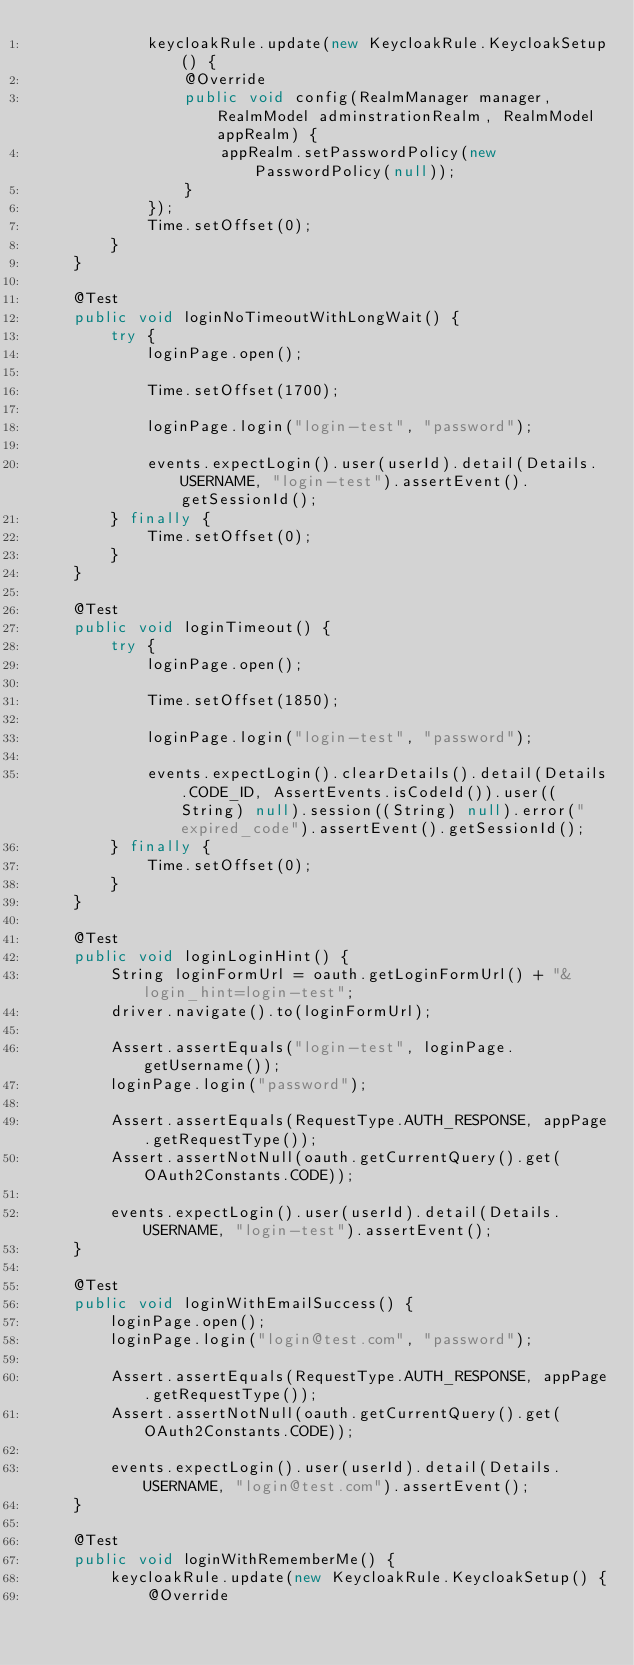Convert code to text. <code><loc_0><loc_0><loc_500><loc_500><_Java_>            keycloakRule.update(new KeycloakRule.KeycloakSetup() {
                @Override
                public void config(RealmManager manager, RealmModel adminstrationRealm, RealmModel appRealm) {
                    appRealm.setPasswordPolicy(new PasswordPolicy(null));
                }
            });
            Time.setOffset(0);
        }
    }
    
    @Test
    public void loginNoTimeoutWithLongWait() {
        try {
            loginPage.open();

            Time.setOffset(1700);

            loginPage.login("login-test", "password");

            events.expectLogin().user(userId).detail(Details.USERNAME, "login-test").assertEvent().getSessionId();
        } finally {
            Time.setOffset(0);
        }
    }

    @Test
    public void loginTimeout() {
        try {
            loginPage.open();

            Time.setOffset(1850);

            loginPage.login("login-test", "password");

            events.expectLogin().clearDetails().detail(Details.CODE_ID, AssertEvents.isCodeId()).user((String) null).session((String) null).error("expired_code").assertEvent().getSessionId();
        } finally {
            Time.setOffset(0);
        }
    }

    @Test
    public void loginLoginHint() {
        String loginFormUrl = oauth.getLoginFormUrl() + "&login_hint=login-test";
        driver.navigate().to(loginFormUrl);

        Assert.assertEquals("login-test", loginPage.getUsername());
        loginPage.login("password");

        Assert.assertEquals(RequestType.AUTH_RESPONSE, appPage.getRequestType());
        Assert.assertNotNull(oauth.getCurrentQuery().get(OAuth2Constants.CODE));

        events.expectLogin().user(userId).detail(Details.USERNAME, "login-test").assertEvent();
    }

    @Test
    public void loginWithEmailSuccess() {
        loginPage.open();
        loginPage.login("login@test.com", "password");

        Assert.assertEquals(RequestType.AUTH_RESPONSE, appPage.getRequestType());
        Assert.assertNotNull(oauth.getCurrentQuery().get(OAuth2Constants.CODE));

        events.expectLogin().user(userId).detail(Details.USERNAME, "login@test.com").assertEvent();
    }

    @Test
    public void loginWithRememberMe() {
        keycloakRule.update(new KeycloakRule.KeycloakSetup() {
            @Override</code> 